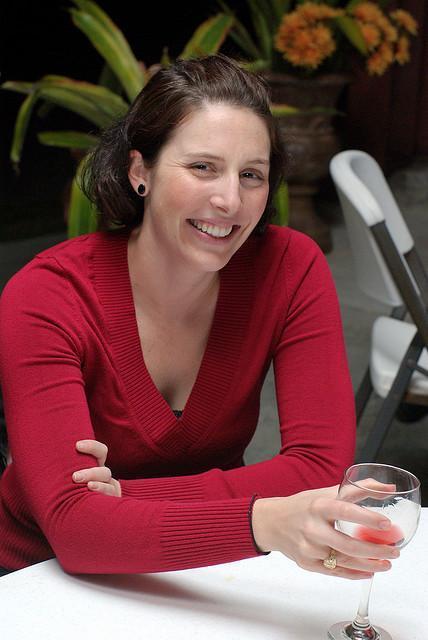How many people are in this picture?
Give a very brief answer. 1. How many faces do you see?
Give a very brief answer. 1. How many people are in the picture?
Give a very brief answer. 1. How many potted plants are in the photo?
Give a very brief answer. 2. 